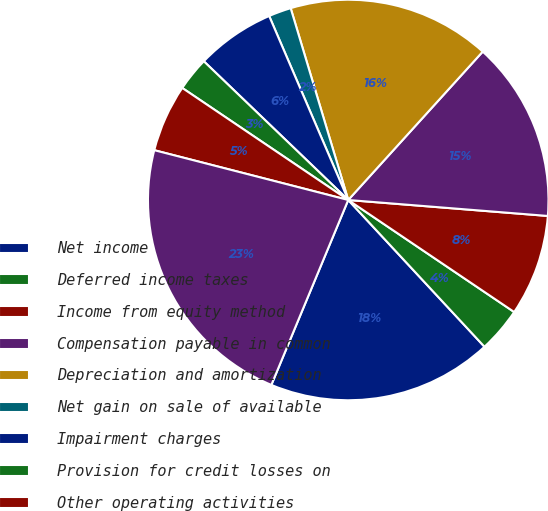<chart> <loc_0><loc_0><loc_500><loc_500><pie_chart><fcel>Net income<fcel>Deferred income taxes<fcel>Income from equity method<fcel>Compensation payable in common<fcel>Depreciation and amortization<fcel>Net gain on sale of available<fcel>Impairment charges<fcel>Provision for credit losses on<fcel>Other operating activities<fcel>Cash deposited with clearing<nl><fcel>18.18%<fcel>3.64%<fcel>8.18%<fcel>14.55%<fcel>16.36%<fcel>1.82%<fcel>6.36%<fcel>2.73%<fcel>5.45%<fcel>22.73%<nl></chart> 